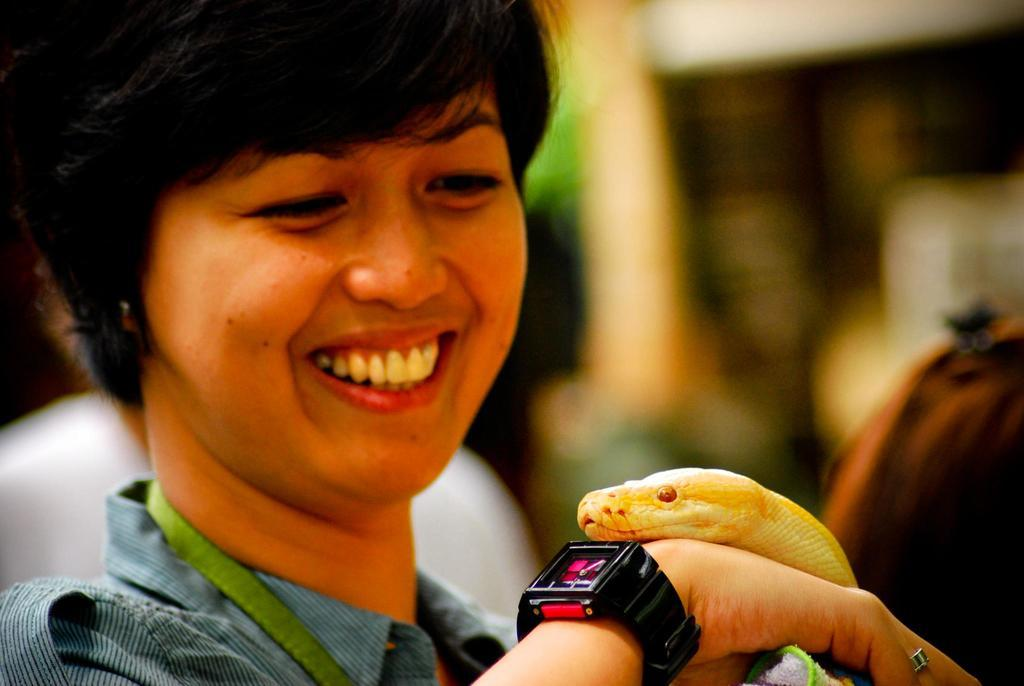Who is present in the image? There is a woman in the image. What is the woman doing in the image? The woman is smiling in the image. Can you describe the other person in the image? There is another person in the background of the image. What type of blade is being used by the woman in the image? There is no blade present in the image; the woman is simply smiling. 